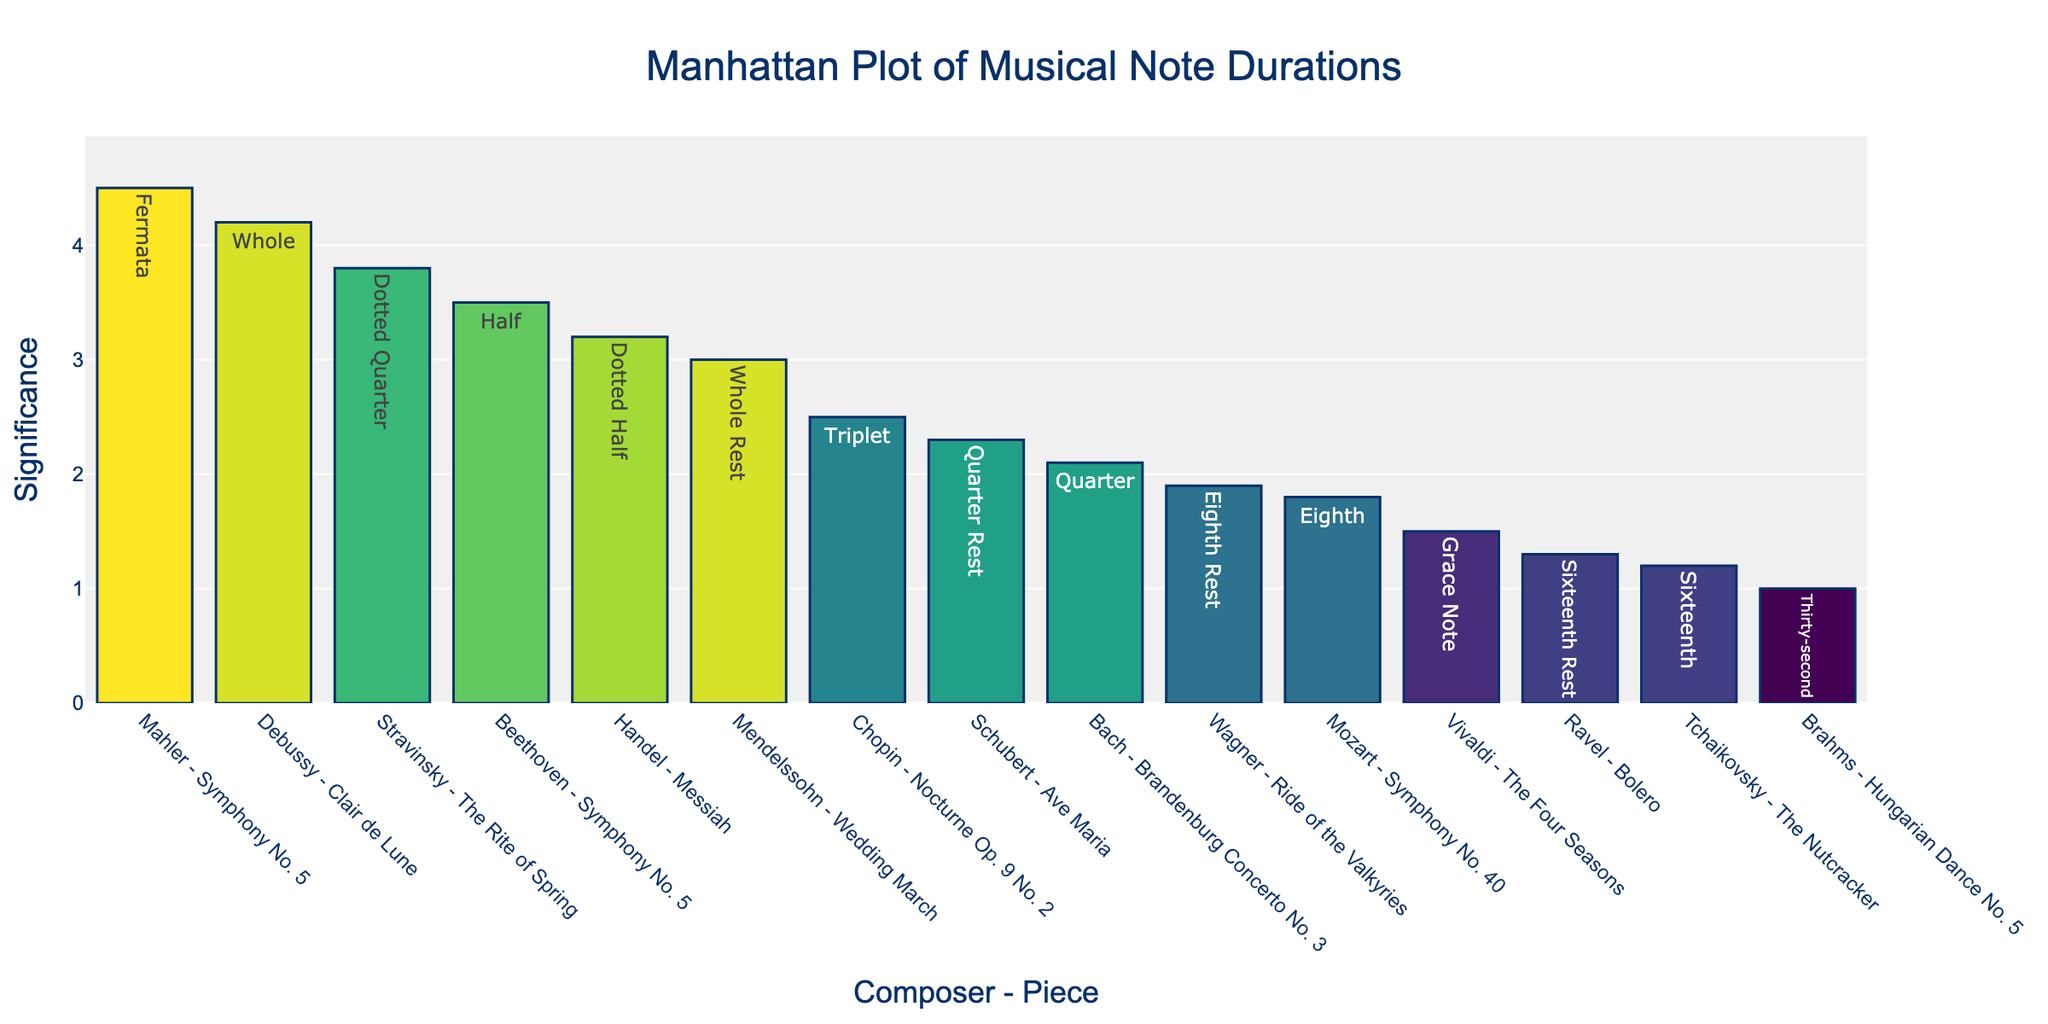What does the title of the plot indicate? The title of the plot is "Manhattan Plot of Musical Note Durations," which suggests that the plot visualizes the significance of various musical note durations in different classical compositions.
Answer: Manhattan Plot of Musical Note Durations How are the composers and pieces represented on the x-axis? The x-axis is labeled with the concatenation of the composer and the piece in the format "Composer - Piece." Each bar corresponds to this combination.
Answer: Composer - Piece Which composer and piece combination has the highest significance? The highest bar in the plot indicates the composer and piece combination with the highest significance. By looking at the plot, we can see that "Mahler - Symphony No. 5" has the highest bar.
Answer: Mahler - Symphony No. 5 How many unique composer-piece combinations are shown in the plot? By counting the distinct bars on the x-axis of the plot, we can determine the number of unique composer-piece combinations. The plot shows 15 distinct bars.
Answer: 15 Which note has the longest duration according to the plot? To identify the note with the longest duration, hover over the bars to see the duration and the corresponding note. The "Whole" note in "Debussy - Clair de Lune" has a duration of 2.0 seconds.
Answer: Whole (Debussy - Clair de Lune) What is the significance value for Beethoven's "Symphony No. 5"? Locate the bar associated with "Beethoven - Symphony No. 5" and read its height or hover over it to display the significance value. The significance for this piece is 3.5.
Answer: 3.5 Which composer and piece have the least significance, and what is the value? Identify the shortest bar in the plot to find the composer-piece combination with the least significance. The shortest bar corresponds to "Brahms - Hungarian Dance No. 5" with a significance of 1.0.
Answer: Brahms - Hungarian Dance No. 5, 1.0 Compare the significance of Bach's "Brandenburg Concerto No. 3" and Chopin's "Nocturne Op. 9 No. 2". Which one is higher? Locate the bars for "Bach - Brandenburg Concerto No. 3" and "Chopin - Nocturne Op. 9 No. 2" and compare their heights or hover text. Bach's piece has a significance of 2.1, while Chopin's piece has a significance of 2.5.
Answer: Chopin's "Nocturne Op. 9 No. 2" What is the difference in significance between Mozart's "Symphony No. 40" and Wagner's "Ride of the Valkyries"? Subtract the significance value of Wagner's piece from Mozart's piece. The significance for Mozart's piece is 1.8, and for Wagner's piece is 1.9. The difference is 1.9 - 1.8 = 0.1.
Answer: 0.1 What color gradient is used to represent the marker color in the plot? The plot uses a gradient color scale called 'Viridis' to represent the marker color, which corresponds to the logarithmic values of the note durations. The colors range from one hue to another in a continuous manner.
Answer: Viridis 